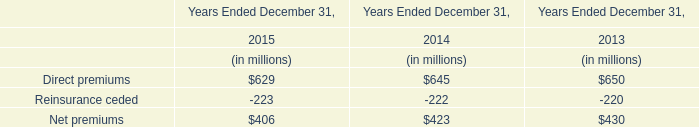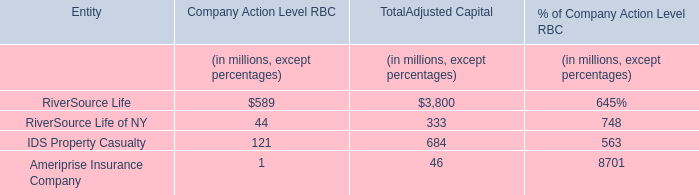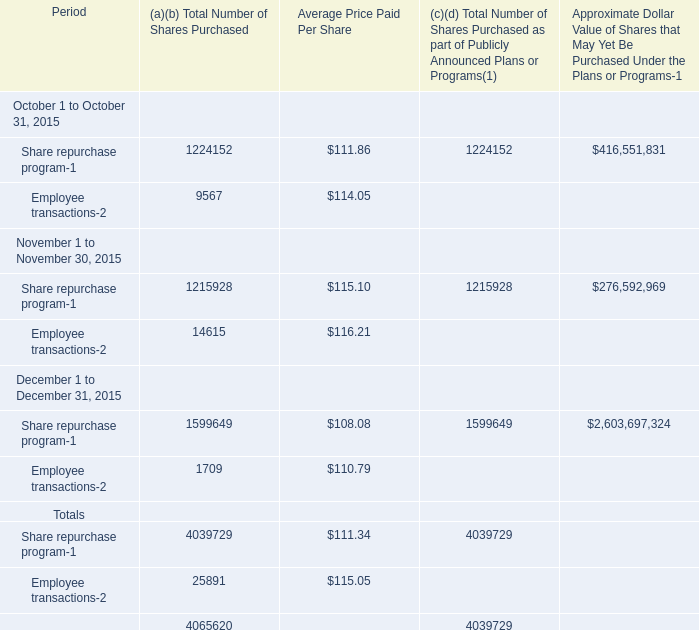What is the proportion of Share repurchase program in October to the total Share repurchase program of the Fourth Quarter in terms of Total Number of Shares Purchased in 2015? 
Computations: (1224152 / 4039729)
Answer: 0.30303. 